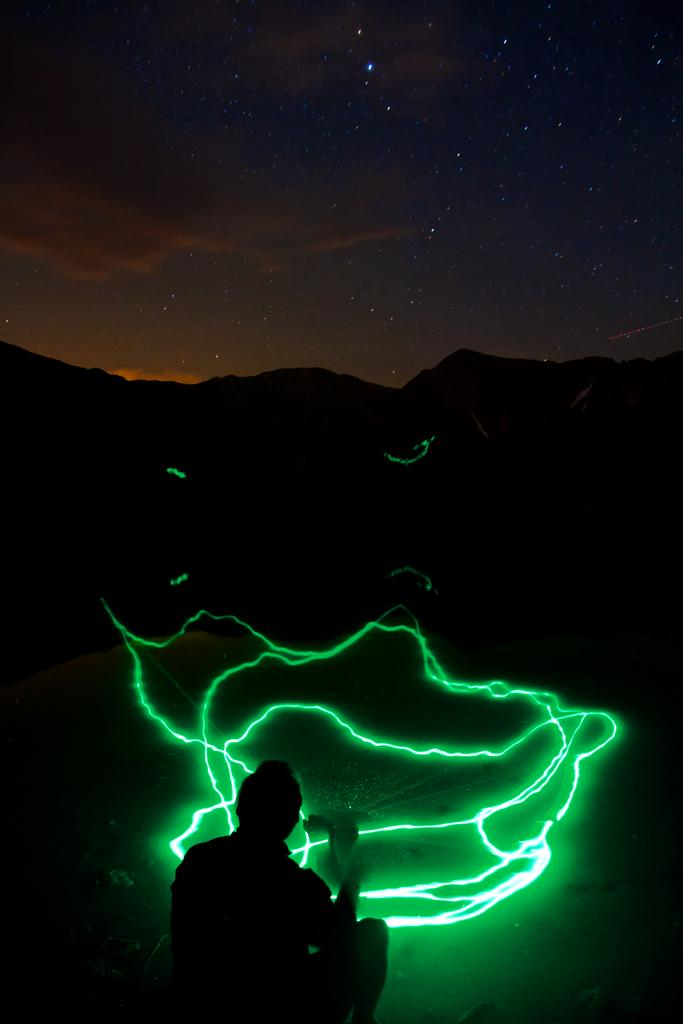What is the color of the background in the image? The background of the image is dark. What can be seen in the sky at the top of the image? The sky with stars is visible at the top of the image. What type of light is present at the bottom of the image? There is a green laser light at the bottom of the image. Can you describe the person in the image? There is a person in the image, but their appearance or actions are not specified in the provided facts. What language is the laborer speaking in the image? There is no laborer present in the image, nor is there any information about spoken language. 